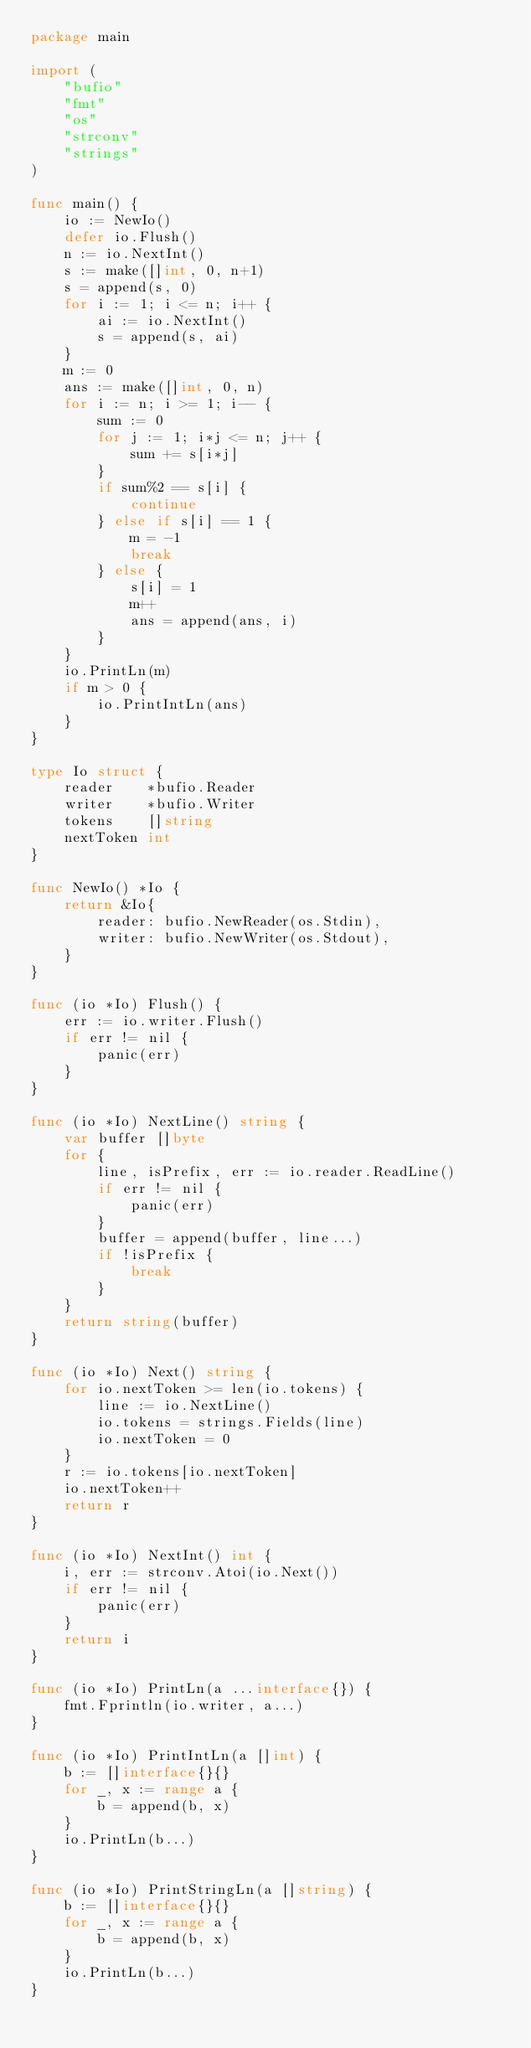<code> <loc_0><loc_0><loc_500><loc_500><_Go_>package main

import (
	"bufio"
	"fmt"
	"os"
	"strconv"
	"strings"
)

func main() {
	io := NewIo()
	defer io.Flush()
	n := io.NextInt()
	s := make([]int, 0, n+1)
	s = append(s, 0)
	for i := 1; i <= n; i++ {
		ai := io.NextInt()
		s = append(s, ai)
	}
	m := 0
	ans := make([]int, 0, n)
	for i := n; i >= 1; i-- {
		sum := 0
		for j := 1; i*j <= n; j++ {
			sum += s[i*j]
		}
		if sum%2 == s[i] {
			continue
		} else if s[i] == 1 {
			m = -1
			break
		} else {
			s[i] = 1
			m++
			ans = append(ans, i)
		}
	}
	io.PrintLn(m)
	if m > 0 {
		io.PrintIntLn(ans)
	}
}

type Io struct {
	reader    *bufio.Reader
	writer    *bufio.Writer
	tokens    []string
	nextToken int
}

func NewIo() *Io {
	return &Io{
		reader: bufio.NewReader(os.Stdin),
		writer: bufio.NewWriter(os.Stdout),
	}
}

func (io *Io) Flush() {
	err := io.writer.Flush()
	if err != nil {
		panic(err)
	}
}

func (io *Io) NextLine() string {
	var buffer []byte
	for {
		line, isPrefix, err := io.reader.ReadLine()
		if err != nil {
			panic(err)
		}
		buffer = append(buffer, line...)
		if !isPrefix {
			break
		}
	}
	return string(buffer)
}

func (io *Io) Next() string {
	for io.nextToken >= len(io.tokens) {
		line := io.NextLine()
		io.tokens = strings.Fields(line)
		io.nextToken = 0
	}
	r := io.tokens[io.nextToken]
	io.nextToken++
	return r
}

func (io *Io) NextInt() int {
	i, err := strconv.Atoi(io.Next())
	if err != nil {
		panic(err)
	}
	return i
}

func (io *Io) PrintLn(a ...interface{}) {
	fmt.Fprintln(io.writer, a...)
}

func (io *Io) PrintIntLn(a []int) {
	b := []interface{}{}
	for _, x := range a {
		b = append(b, x)
	}
	io.PrintLn(b...)
}

func (io *Io) PrintStringLn(a []string) {
	b := []interface{}{}
	for _, x := range a {
		b = append(b, x)
	}
	io.PrintLn(b...)
}
</code> 